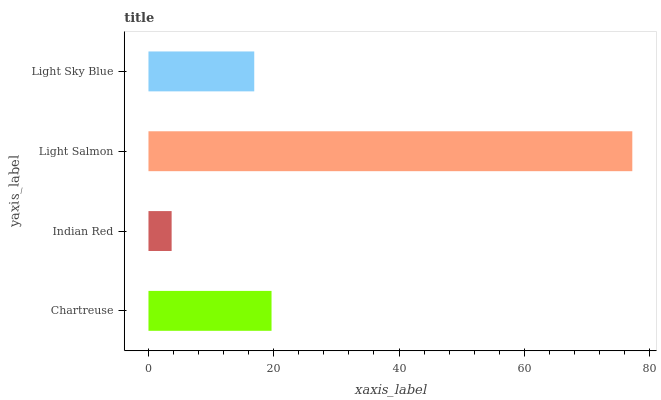Is Indian Red the minimum?
Answer yes or no. Yes. Is Light Salmon the maximum?
Answer yes or no. Yes. Is Light Salmon the minimum?
Answer yes or no. No. Is Indian Red the maximum?
Answer yes or no. No. Is Light Salmon greater than Indian Red?
Answer yes or no. Yes. Is Indian Red less than Light Salmon?
Answer yes or no. Yes. Is Indian Red greater than Light Salmon?
Answer yes or no. No. Is Light Salmon less than Indian Red?
Answer yes or no. No. Is Chartreuse the high median?
Answer yes or no. Yes. Is Light Sky Blue the low median?
Answer yes or no. Yes. Is Light Salmon the high median?
Answer yes or no. No. Is Light Salmon the low median?
Answer yes or no. No. 